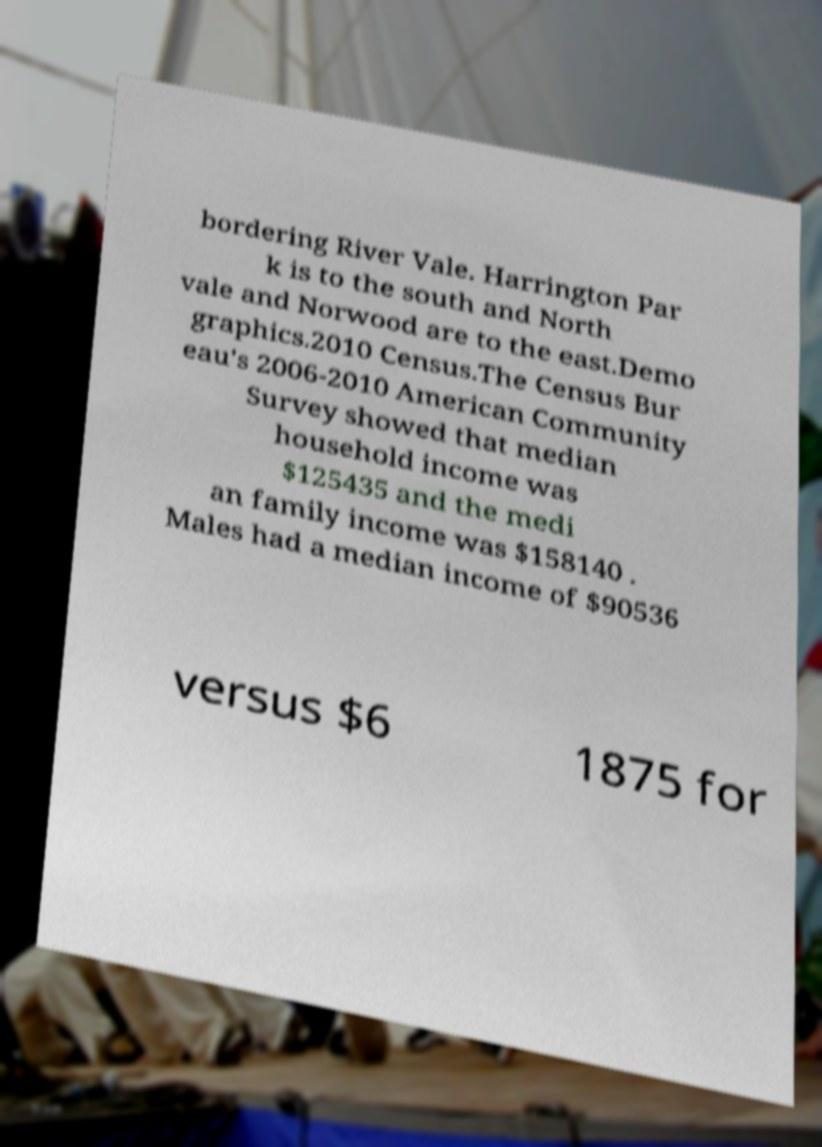What messages or text are displayed in this image? I need them in a readable, typed format. bordering River Vale. Harrington Par k is to the south and North vale and Norwood are to the east.Demo graphics.2010 Census.The Census Bur eau's 2006-2010 American Community Survey showed that median household income was $125435 and the medi an family income was $158140 . Males had a median income of $90536 versus $6 1875 for 